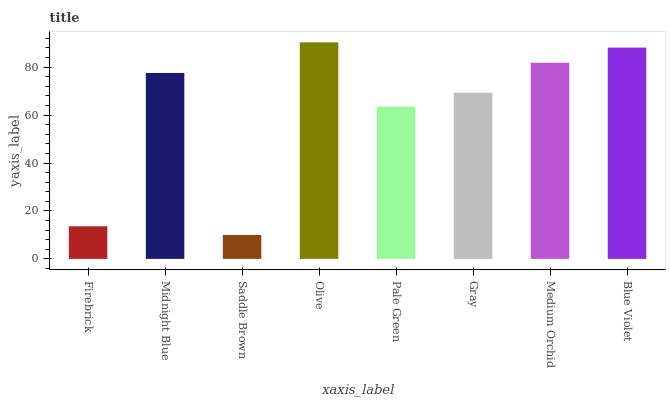Is Saddle Brown the minimum?
Answer yes or no. Yes. Is Olive the maximum?
Answer yes or no. Yes. Is Midnight Blue the minimum?
Answer yes or no. No. Is Midnight Blue the maximum?
Answer yes or no. No. Is Midnight Blue greater than Firebrick?
Answer yes or no. Yes. Is Firebrick less than Midnight Blue?
Answer yes or no. Yes. Is Firebrick greater than Midnight Blue?
Answer yes or no. No. Is Midnight Blue less than Firebrick?
Answer yes or no. No. Is Midnight Blue the high median?
Answer yes or no. Yes. Is Gray the low median?
Answer yes or no. Yes. Is Gray the high median?
Answer yes or no. No. Is Medium Orchid the low median?
Answer yes or no. No. 